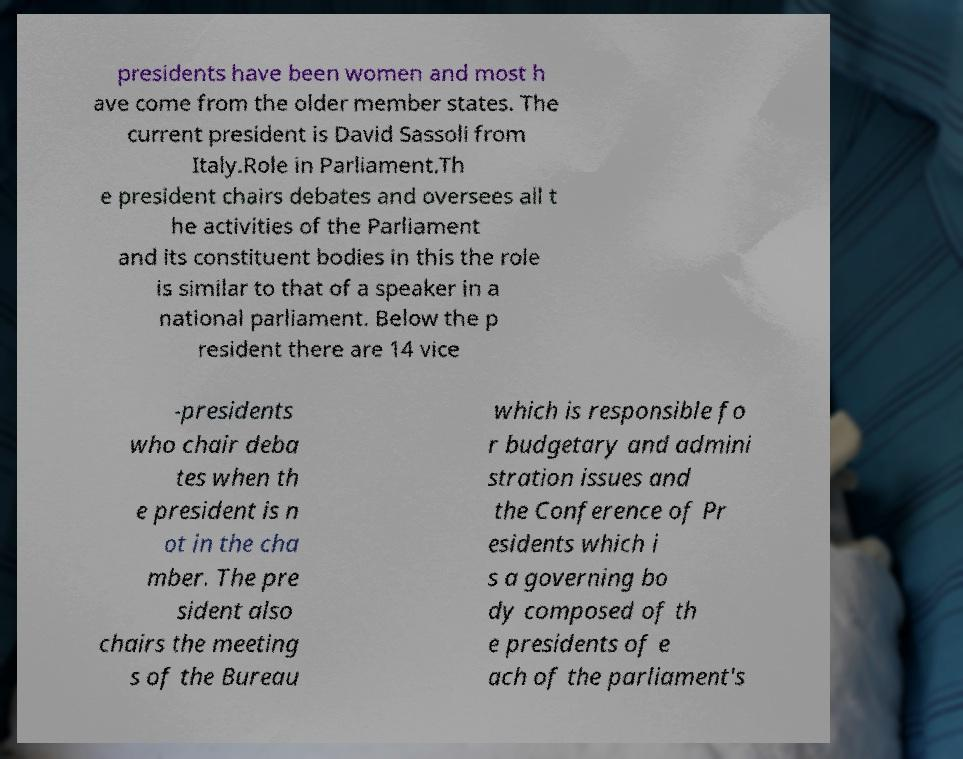Please identify and transcribe the text found in this image. presidents have been women and most h ave come from the older member states. The current president is David Sassoli from Italy.Role in Parliament.Th e president chairs debates and oversees all t he activities of the Parliament and its constituent bodies in this the role is similar to that of a speaker in a national parliament. Below the p resident there are 14 vice -presidents who chair deba tes when th e president is n ot in the cha mber. The pre sident also chairs the meeting s of the Bureau which is responsible fo r budgetary and admini stration issues and the Conference of Pr esidents which i s a governing bo dy composed of th e presidents of e ach of the parliament's 